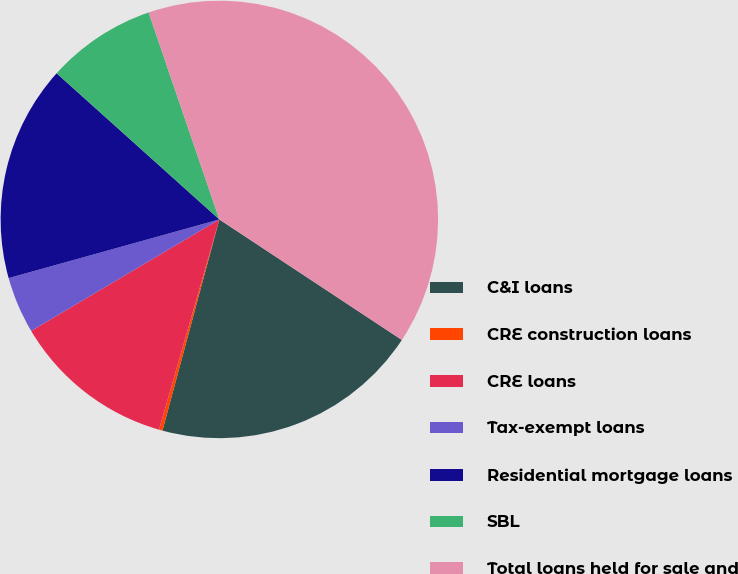Convert chart to OTSL. <chart><loc_0><loc_0><loc_500><loc_500><pie_chart><fcel>C&I loans<fcel>CRE construction loans<fcel>CRE loans<fcel>Tax-exempt loans<fcel>Residential mortgage loans<fcel>SBL<fcel>Total loans held for sale and<nl><fcel>19.9%<fcel>0.26%<fcel>12.04%<fcel>4.19%<fcel>15.97%<fcel>8.11%<fcel>39.53%<nl></chart> 